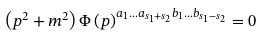<formula> <loc_0><loc_0><loc_500><loc_500>\left ( p ^ { 2 } + m ^ { 2 } \right ) \Phi \left ( p \right ) ^ { a _ { 1 } \dots a _ { s _ { 1 } + s _ { 2 } } b _ { 1 } \dots b _ { s _ { 1 } - s _ { 2 } } } = 0</formula> 